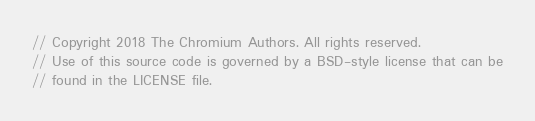<code> <loc_0><loc_0><loc_500><loc_500><_ObjectiveC_>// Copyright 2018 The Chromium Authors. All rights reserved.
// Use of this source code is governed by a BSD-style license that can be
// found in the LICENSE file.
</code> 